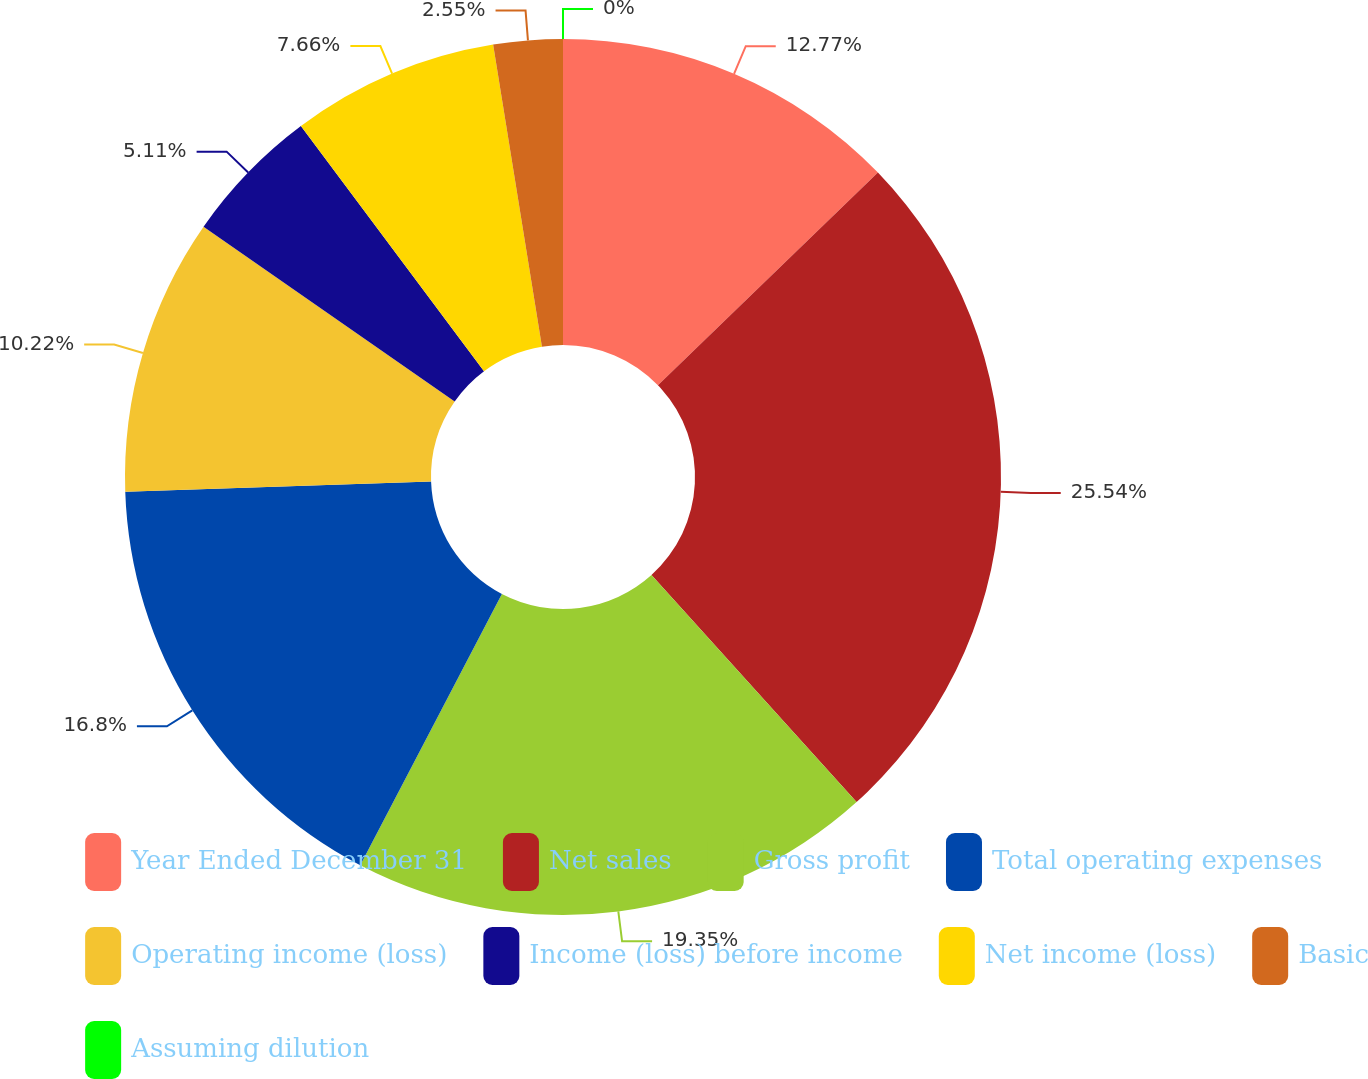Convert chart to OTSL. <chart><loc_0><loc_0><loc_500><loc_500><pie_chart><fcel>Year Ended December 31<fcel>Net sales<fcel>Gross profit<fcel>Total operating expenses<fcel>Operating income (loss)<fcel>Income (loss) before income<fcel>Net income (loss)<fcel>Basic<fcel>Assuming dilution<nl><fcel>12.77%<fcel>25.54%<fcel>19.35%<fcel>16.8%<fcel>10.22%<fcel>5.11%<fcel>7.66%<fcel>2.55%<fcel>0.0%<nl></chart> 